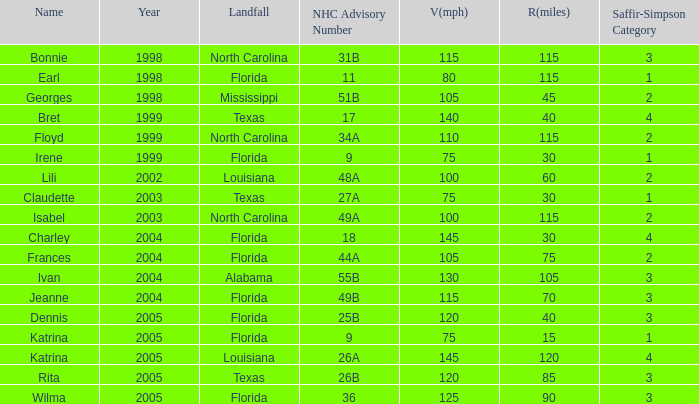What was the least v(mph) for a saffir-simpson scale 4 in 2005? 145.0. 